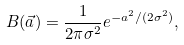<formula> <loc_0><loc_0><loc_500><loc_500>B ( \vec { a } ) = \frac { 1 } { 2 \pi \sigma ^ { 2 } } e ^ { - a ^ { 2 } / ( 2 \sigma ^ { 2 } ) } ,</formula> 